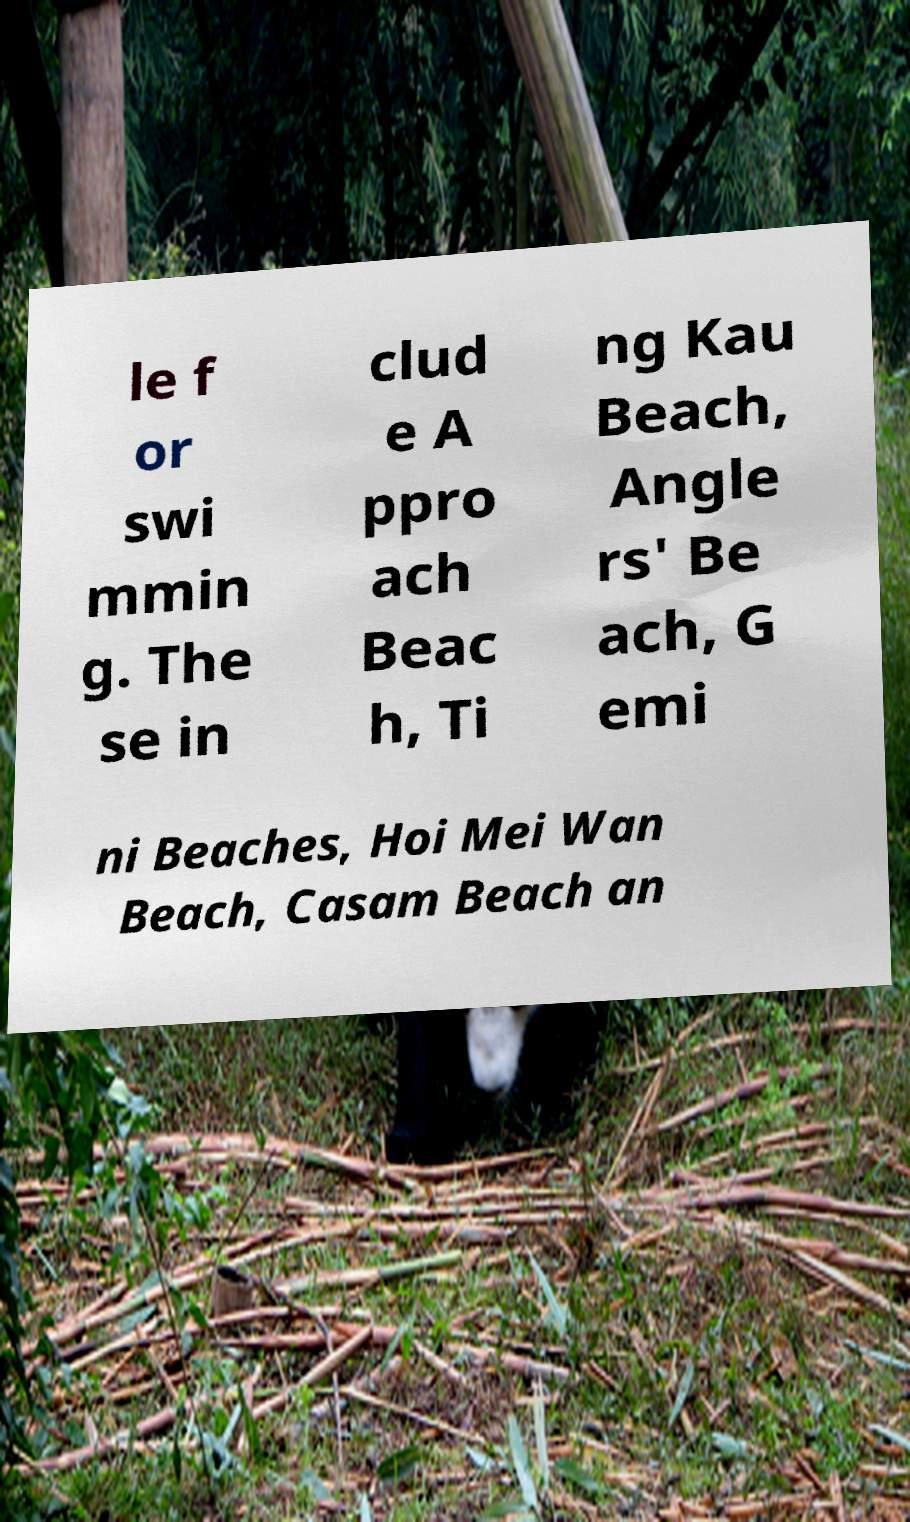Can you read and provide the text displayed in the image?This photo seems to have some interesting text. Can you extract and type it out for me? le f or swi mmin g. The se in clud e A ppro ach Beac h, Ti ng Kau Beach, Angle rs' Be ach, G emi ni Beaches, Hoi Mei Wan Beach, Casam Beach an 